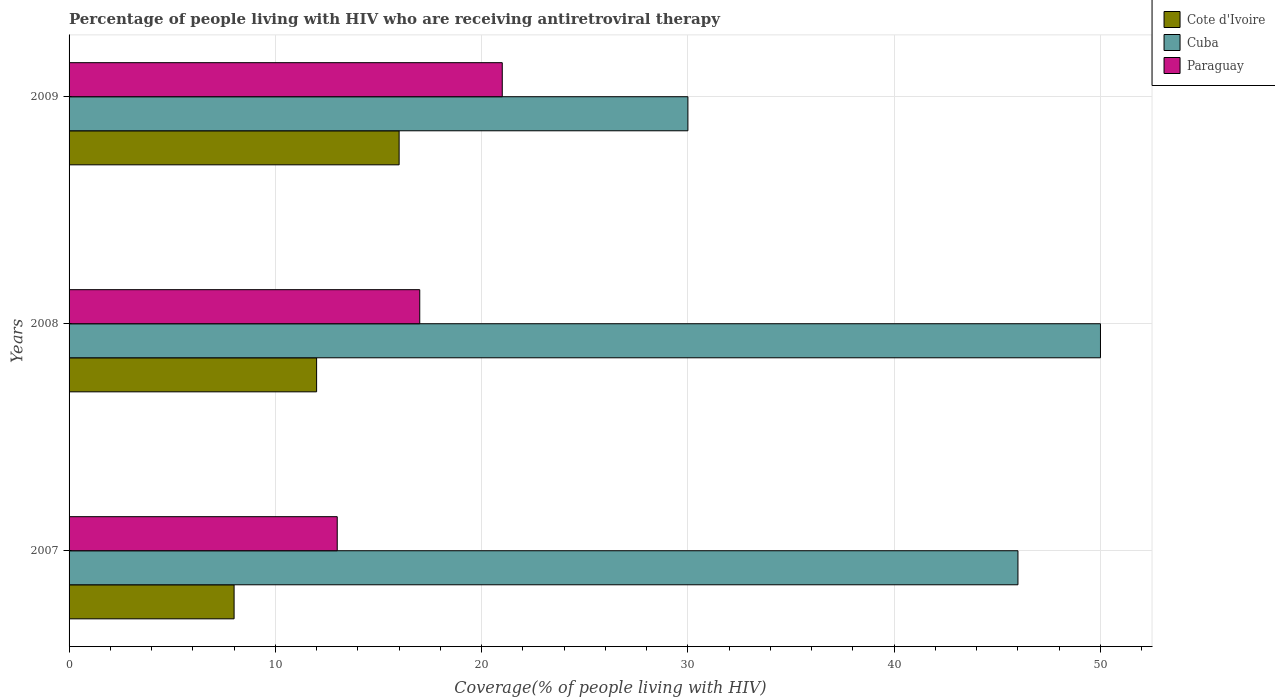How many different coloured bars are there?
Your response must be concise. 3. How many groups of bars are there?
Keep it short and to the point. 3. Are the number of bars per tick equal to the number of legend labels?
Keep it short and to the point. Yes. What is the label of the 1st group of bars from the top?
Offer a very short reply. 2009. In how many cases, is the number of bars for a given year not equal to the number of legend labels?
Your response must be concise. 0. What is the percentage of the HIV infected people who are receiving antiretroviral therapy in Paraguay in 2007?
Offer a very short reply. 13. Across all years, what is the maximum percentage of the HIV infected people who are receiving antiretroviral therapy in Cuba?
Offer a terse response. 50. Across all years, what is the minimum percentage of the HIV infected people who are receiving antiretroviral therapy in Cote d'Ivoire?
Make the answer very short. 8. In which year was the percentage of the HIV infected people who are receiving antiretroviral therapy in Cuba minimum?
Provide a succinct answer. 2009. What is the total percentage of the HIV infected people who are receiving antiretroviral therapy in Paraguay in the graph?
Ensure brevity in your answer.  51. What is the difference between the percentage of the HIV infected people who are receiving antiretroviral therapy in Cote d'Ivoire in 2008 and that in 2009?
Provide a succinct answer. -4. What is the difference between the percentage of the HIV infected people who are receiving antiretroviral therapy in Paraguay in 2009 and the percentage of the HIV infected people who are receiving antiretroviral therapy in Cuba in 2007?
Offer a terse response. -25. In the year 2009, what is the difference between the percentage of the HIV infected people who are receiving antiretroviral therapy in Cuba and percentage of the HIV infected people who are receiving antiretroviral therapy in Cote d'Ivoire?
Offer a terse response. 14. In how many years, is the percentage of the HIV infected people who are receiving antiretroviral therapy in Cuba greater than 42 %?
Your response must be concise. 2. What is the ratio of the percentage of the HIV infected people who are receiving antiretroviral therapy in Cuba in 2008 to that in 2009?
Your response must be concise. 1.67. Is the percentage of the HIV infected people who are receiving antiretroviral therapy in Cuba in 2008 less than that in 2009?
Provide a succinct answer. No. Is the difference between the percentage of the HIV infected people who are receiving antiretroviral therapy in Cuba in 2008 and 2009 greater than the difference between the percentage of the HIV infected people who are receiving antiretroviral therapy in Cote d'Ivoire in 2008 and 2009?
Give a very brief answer. Yes. What is the difference between the highest and the second highest percentage of the HIV infected people who are receiving antiretroviral therapy in Paraguay?
Provide a short and direct response. 4. What is the difference between the highest and the lowest percentage of the HIV infected people who are receiving antiretroviral therapy in Paraguay?
Provide a succinct answer. 8. In how many years, is the percentage of the HIV infected people who are receiving antiretroviral therapy in Cote d'Ivoire greater than the average percentage of the HIV infected people who are receiving antiretroviral therapy in Cote d'Ivoire taken over all years?
Ensure brevity in your answer.  1. What does the 3rd bar from the top in 2009 represents?
Offer a very short reply. Cote d'Ivoire. What does the 3rd bar from the bottom in 2007 represents?
Provide a succinct answer. Paraguay. Is it the case that in every year, the sum of the percentage of the HIV infected people who are receiving antiretroviral therapy in Cote d'Ivoire and percentage of the HIV infected people who are receiving antiretroviral therapy in Paraguay is greater than the percentage of the HIV infected people who are receiving antiretroviral therapy in Cuba?
Your answer should be very brief. No. How many bars are there?
Offer a very short reply. 9. Are the values on the major ticks of X-axis written in scientific E-notation?
Provide a short and direct response. No. Does the graph contain grids?
Your answer should be compact. Yes. How many legend labels are there?
Keep it short and to the point. 3. What is the title of the graph?
Give a very brief answer. Percentage of people living with HIV who are receiving antiretroviral therapy. What is the label or title of the X-axis?
Give a very brief answer. Coverage(% of people living with HIV). What is the Coverage(% of people living with HIV) of Cote d'Ivoire in 2007?
Offer a very short reply. 8. What is the Coverage(% of people living with HIV) in Cuba in 2007?
Offer a terse response. 46. What is the Coverage(% of people living with HIV) of Paraguay in 2007?
Your answer should be very brief. 13. What is the Coverage(% of people living with HIV) of Cote d'Ivoire in 2008?
Ensure brevity in your answer.  12. What is the Coverage(% of people living with HIV) of Cote d'Ivoire in 2009?
Your answer should be compact. 16. What is the Coverage(% of people living with HIV) in Cuba in 2009?
Make the answer very short. 30. What is the Coverage(% of people living with HIV) of Paraguay in 2009?
Offer a very short reply. 21. Across all years, what is the maximum Coverage(% of people living with HIV) in Cote d'Ivoire?
Ensure brevity in your answer.  16. Across all years, what is the maximum Coverage(% of people living with HIV) of Cuba?
Give a very brief answer. 50. Across all years, what is the minimum Coverage(% of people living with HIV) in Paraguay?
Offer a terse response. 13. What is the total Coverage(% of people living with HIV) in Cuba in the graph?
Your response must be concise. 126. What is the total Coverage(% of people living with HIV) in Paraguay in the graph?
Ensure brevity in your answer.  51. What is the difference between the Coverage(% of people living with HIV) of Paraguay in 2007 and that in 2008?
Your answer should be very brief. -4. What is the difference between the Coverage(% of people living with HIV) of Cote d'Ivoire in 2007 and that in 2009?
Provide a short and direct response. -8. What is the difference between the Coverage(% of people living with HIV) of Cuba in 2007 and that in 2009?
Keep it short and to the point. 16. What is the difference between the Coverage(% of people living with HIV) in Paraguay in 2007 and that in 2009?
Provide a short and direct response. -8. What is the difference between the Coverage(% of people living with HIV) in Cote d'Ivoire in 2008 and that in 2009?
Your answer should be very brief. -4. What is the difference between the Coverage(% of people living with HIV) of Cuba in 2008 and that in 2009?
Offer a very short reply. 20. What is the difference between the Coverage(% of people living with HIV) in Paraguay in 2008 and that in 2009?
Keep it short and to the point. -4. What is the difference between the Coverage(% of people living with HIV) of Cote d'Ivoire in 2007 and the Coverage(% of people living with HIV) of Cuba in 2008?
Keep it short and to the point. -42. What is the difference between the Coverage(% of people living with HIV) of Cote d'Ivoire in 2008 and the Coverage(% of people living with HIV) of Cuba in 2009?
Provide a short and direct response. -18. What is the difference between the Coverage(% of people living with HIV) of Cote d'Ivoire in 2008 and the Coverage(% of people living with HIV) of Paraguay in 2009?
Give a very brief answer. -9. What is the difference between the Coverage(% of people living with HIV) of Cuba in 2008 and the Coverage(% of people living with HIV) of Paraguay in 2009?
Give a very brief answer. 29. What is the average Coverage(% of people living with HIV) in Cuba per year?
Provide a succinct answer. 42. What is the average Coverage(% of people living with HIV) in Paraguay per year?
Give a very brief answer. 17. In the year 2007, what is the difference between the Coverage(% of people living with HIV) of Cote d'Ivoire and Coverage(% of people living with HIV) of Cuba?
Offer a terse response. -38. In the year 2007, what is the difference between the Coverage(% of people living with HIV) in Cote d'Ivoire and Coverage(% of people living with HIV) in Paraguay?
Keep it short and to the point. -5. In the year 2007, what is the difference between the Coverage(% of people living with HIV) in Cuba and Coverage(% of people living with HIV) in Paraguay?
Provide a short and direct response. 33. In the year 2008, what is the difference between the Coverage(% of people living with HIV) of Cote d'Ivoire and Coverage(% of people living with HIV) of Cuba?
Keep it short and to the point. -38. In the year 2008, what is the difference between the Coverage(% of people living with HIV) in Cote d'Ivoire and Coverage(% of people living with HIV) in Paraguay?
Your answer should be compact. -5. In the year 2009, what is the difference between the Coverage(% of people living with HIV) of Cote d'Ivoire and Coverage(% of people living with HIV) of Cuba?
Keep it short and to the point. -14. In the year 2009, what is the difference between the Coverage(% of people living with HIV) in Cuba and Coverage(% of people living with HIV) in Paraguay?
Provide a succinct answer. 9. What is the ratio of the Coverage(% of people living with HIV) of Cote d'Ivoire in 2007 to that in 2008?
Provide a succinct answer. 0.67. What is the ratio of the Coverage(% of people living with HIV) of Cuba in 2007 to that in 2008?
Offer a terse response. 0.92. What is the ratio of the Coverage(% of people living with HIV) in Paraguay in 2007 to that in 2008?
Your response must be concise. 0.76. What is the ratio of the Coverage(% of people living with HIV) of Cote d'Ivoire in 2007 to that in 2009?
Provide a short and direct response. 0.5. What is the ratio of the Coverage(% of people living with HIV) in Cuba in 2007 to that in 2009?
Keep it short and to the point. 1.53. What is the ratio of the Coverage(% of people living with HIV) in Paraguay in 2007 to that in 2009?
Make the answer very short. 0.62. What is the ratio of the Coverage(% of people living with HIV) of Cote d'Ivoire in 2008 to that in 2009?
Your answer should be very brief. 0.75. What is the ratio of the Coverage(% of people living with HIV) in Cuba in 2008 to that in 2009?
Provide a succinct answer. 1.67. What is the ratio of the Coverage(% of people living with HIV) of Paraguay in 2008 to that in 2009?
Provide a succinct answer. 0.81. What is the difference between the highest and the second highest Coverage(% of people living with HIV) of Cote d'Ivoire?
Make the answer very short. 4. What is the difference between the highest and the second highest Coverage(% of people living with HIV) of Cuba?
Provide a short and direct response. 4. What is the difference between the highest and the second highest Coverage(% of people living with HIV) in Paraguay?
Your response must be concise. 4. 